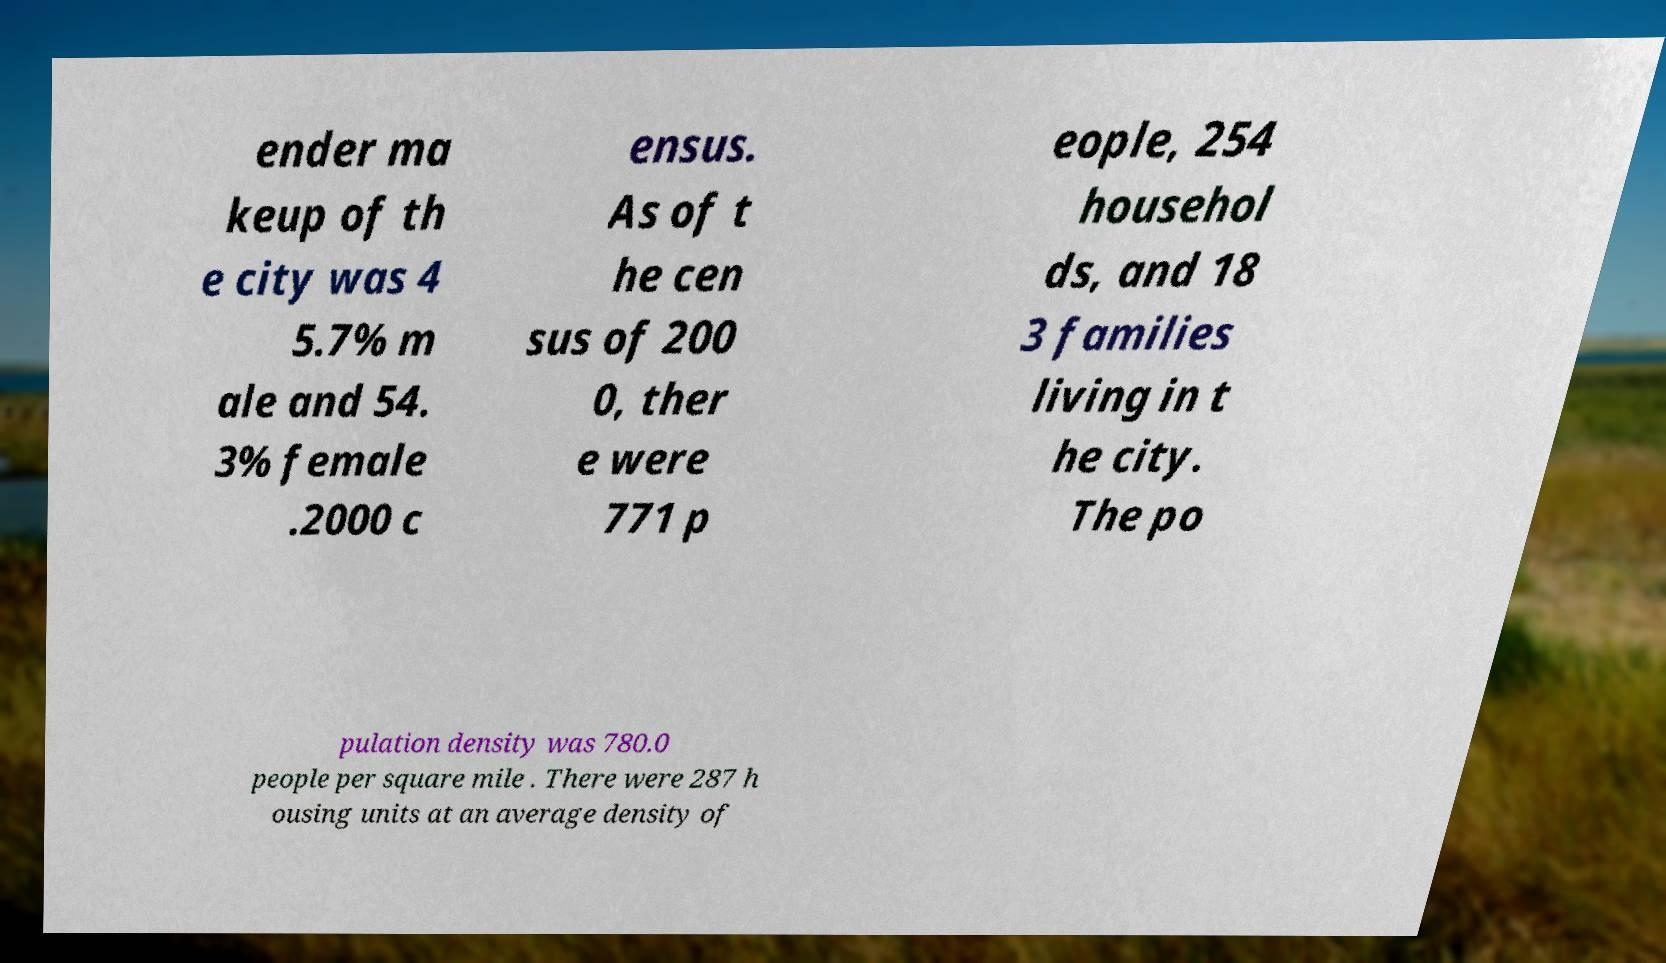For documentation purposes, I need the text within this image transcribed. Could you provide that? ender ma keup of th e city was 4 5.7% m ale and 54. 3% female .2000 c ensus. As of t he cen sus of 200 0, ther e were 771 p eople, 254 househol ds, and 18 3 families living in t he city. The po pulation density was 780.0 people per square mile . There were 287 h ousing units at an average density of 